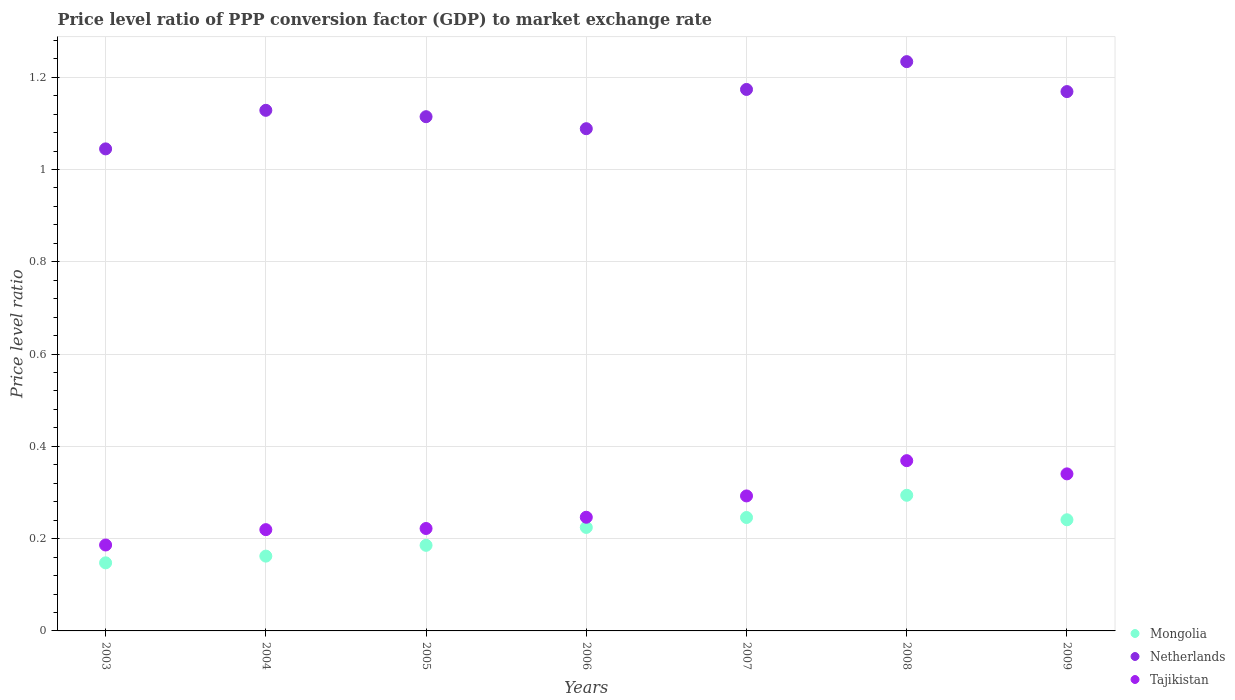Is the number of dotlines equal to the number of legend labels?
Offer a terse response. Yes. What is the price level ratio in Tajikistan in 2008?
Give a very brief answer. 0.37. Across all years, what is the maximum price level ratio in Netherlands?
Make the answer very short. 1.23. Across all years, what is the minimum price level ratio in Tajikistan?
Offer a very short reply. 0.19. In which year was the price level ratio in Tajikistan maximum?
Provide a short and direct response. 2008. In which year was the price level ratio in Mongolia minimum?
Your response must be concise. 2003. What is the total price level ratio in Netherlands in the graph?
Ensure brevity in your answer.  7.95. What is the difference between the price level ratio in Tajikistan in 2003 and that in 2005?
Keep it short and to the point. -0.04. What is the difference between the price level ratio in Netherlands in 2004 and the price level ratio in Mongolia in 2007?
Your answer should be very brief. 0.88. What is the average price level ratio in Tajikistan per year?
Offer a very short reply. 0.27. In the year 2003, what is the difference between the price level ratio in Tajikistan and price level ratio in Netherlands?
Your answer should be compact. -0.86. What is the ratio of the price level ratio in Mongolia in 2004 to that in 2007?
Your answer should be very brief. 0.66. Is the price level ratio in Netherlands in 2003 less than that in 2006?
Your answer should be compact. Yes. What is the difference between the highest and the second highest price level ratio in Mongolia?
Your answer should be very brief. 0.05. What is the difference between the highest and the lowest price level ratio in Tajikistan?
Offer a very short reply. 0.18. In how many years, is the price level ratio in Mongolia greater than the average price level ratio in Mongolia taken over all years?
Keep it short and to the point. 4. Is it the case that in every year, the sum of the price level ratio in Tajikistan and price level ratio in Mongolia  is greater than the price level ratio in Netherlands?
Provide a short and direct response. No. Does the price level ratio in Mongolia monotonically increase over the years?
Ensure brevity in your answer.  No. Is the price level ratio in Mongolia strictly greater than the price level ratio in Netherlands over the years?
Your response must be concise. No. How many years are there in the graph?
Offer a terse response. 7. Does the graph contain any zero values?
Your answer should be very brief. No. Where does the legend appear in the graph?
Offer a very short reply. Bottom right. How are the legend labels stacked?
Offer a terse response. Vertical. What is the title of the graph?
Provide a succinct answer. Price level ratio of PPP conversion factor (GDP) to market exchange rate. Does "Lesotho" appear as one of the legend labels in the graph?
Your answer should be very brief. No. What is the label or title of the X-axis?
Ensure brevity in your answer.  Years. What is the label or title of the Y-axis?
Keep it short and to the point. Price level ratio. What is the Price level ratio of Mongolia in 2003?
Provide a short and direct response. 0.15. What is the Price level ratio in Netherlands in 2003?
Make the answer very short. 1.04. What is the Price level ratio in Tajikistan in 2003?
Your answer should be compact. 0.19. What is the Price level ratio of Mongolia in 2004?
Give a very brief answer. 0.16. What is the Price level ratio in Netherlands in 2004?
Your answer should be compact. 1.13. What is the Price level ratio of Tajikistan in 2004?
Provide a short and direct response. 0.22. What is the Price level ratio in Mongolia in 2005?
Your answer should be very brief. 0.19. What is the Price level ratio of Netherlands in 2005?
Your answer should be very brief. 1.11. What is the Price level ratio in Tajikistan in 2005?
Your response must be concise. 0.22. What is the Price level ratio of Mongolia in 2006?
Keep it short and to the point. 0.22. What is the Price level ratio in Netherlands in 2006?
Offer a terse response. 1.09. What is the Price level ratio in Tajikistan in 2006?
Offer a terse response. 0.25. What is the Price level ratio in Mongolia in 2007?
Your answer should be compact. 0.25. What is the Price level ratio of Netherlands in 2007?
Provide a succinct answer. 1.17. What is the Price level ratio in Tajikistan in 2007?
Ensure brevity in your answer.  0.29. What is the Price level ratio in Mongolia in 2008?
Offer a very short reply. 0.29. What is the Price level ratio in Netherlands in 2008?
Offer a very short reply. 1.23. What is the Price level ratio in Tajikistan in 2008?
Ensure brevity in your answer.  0.37. What is the Price level ratio in Mongolia in 2009?
Provide a succinct answer. 0.24. What is the Price level ratio of Netherlands in 2009?
Provide a short and direct response. 1.17. What is the Price level ratio of Tajikistan in 2009?
Provide a short and direct response. 0.34. Across all years, what is the maximum Price level ratio in Mongolia?
Provide a succinct answer. 0.29. Across all years, what is the maximum Price level ratio of Netherlands?
Provide a short and direct response. 1.23. Across all years, what is the maximum Price level ratio in Tajikistan?
Offer a terse response. 0.37. Across all years, what is the minimum Price level ratio in Mongolia?
Ensure brevity in your answer.  0.15. Across all years, what is the minimum Price level ratio of Netherlands?
Provide a succinct answer. 1.04. Across all years, what is the minimum Price level ratio in Tajikistan?
Ensure brevity in your answer.  0.19. What is the total Price level ratio of Mongolia in the graph?
Ensure brevity in your answer.  1.5. What is the total Price level ratio of Netherlands in the graph?
Keep it short and to the point. 7.95. What is the total Price level ratio in Tajikistan in the graph?
Your response must be concise. 1.88. What is the difference between the Price level ratio in Mongolia in 2003 and that in 2004?
Provide a short and direct response. -0.01. What is the difference between the Price level ratio in Netherlands in 2003 and that in 2004?
Make the answer very short. -0.08. What is the difference between the Price level ratio of Tajikistan in 2003 and that in 2004?
Give a very brief answer. -0.03. What is the difference between the Price level ratio of Mongolia in 2003 and that in 2005?
Offer a terse response. -0.04. What is the difference between the Price level ratio in Netherlands in 2003 and that in 2005?
Your answer should be compact. -0.07. What is the difference between the Price level ratio of Tajikistan in 2003 and that in 2005?
Provide a short and direct response. -0.04. What is the difference between the Price level ratio of Mongolia in 2003 and that in 2006?
Offer a terse response. -0.08. What is the difference between the Price level ratio of Netherlands in 2003 and that in 2006?
Your answer should be compact. -0.04. What is the difference between the Price level ratio of Tajikistan in 2003 and that in 2006?
Provide a short and direct response. -0.06. What is the difference between the Price level ratio in Mongolia in 2003 and that in 2007?
Your answer should be very brief. -0.1. What is the difference between the Price level ratio in Netherlands in 2003 and that in 2007?
Give a very brief answer. -0.13. What is the difference between the Price level ratio in Tajikistan in 2003 and that in 2007?
Give a very brief answer. -0.11. What is the difference between the Price level ratio in Mongolia in 2003 and that in 2008?
Offer a very short reply. -0.15. What is the difference between the Price level ratio in Netherlands in 2003 and that in 2008?
Provide a succinct answer. -0.19. What is the difference between the Price level ratio in Tajikistan in 2003 and that in 2008?
Give a very brief answer. -0.18. What is the difference between the Price level ratio of Mongolia in 2003 and that in 2009?
Ensure brevity in your answer.  -0.09. What is the difference between the Price level ratio in Netherlands in 2003 and that in 2009?
Provide a succinct answer. -0.12. What is the difference between the Price level ratio of Tajikistan in 2003 and that in 2009?
Provide a succinct answer. -0.15. What is the difference between the Price level ratio in Mongolia in 2004 and that in 2005?
Your response must be concise. -0.02. What is the difference between the Price level ratio in Netherlands in 2004 and that in 2005?
Your answer should be compact. 0.01. What is the difference between the Price level ratio of Tajikistan in 2004 and that in 2005?
Provide a short and direct response. -0. What is the difference between the Price level ratio of Mongolia in 2004 and that in 2006?
Provide a short and direct response. -0.06. What is the difference between the Price level ratio of Netherlands in 2004 and that in 2006?
Make the answer very short. 0.04. What is the difference between the Price level ratio of Tajikistan in 2004 and that in 2006?
Your response must be concise. -0.03. What is the difference between the Price level ratio of Mongolia in 2004 and that in 2007?
Your response must be concise. -0.08. What is the difference between the Price level ratio in Netherlands in 2004 and that in 2007?
Give a very brief answer. -0.05. What is the difference between the Price level ratio in Tajikistan in 2004 and that in 2007?
Make the answer very short. -0.07. What is the difference between the Price level ratio in Mongolia in 2004 and that in 2008?
Provide a short and direct response. -0.13. What is the difference between the Price level ratio of Netherlands in 2004 and that in 2008?
Provide a short and direct response. -0.11. What is the difference between the Price level ratio in Tajikistan in 2004 and that in 2008?
Provide a succinct answer. -0.15. What is the difference between the Price level ratio in Mongolia in 2004 and that in 2009?
Keep it short and to the point. -0.08. What is the difference between the Price level ratio of Netherlands in 2004 and that in 2009?
Give a very brief answer. -0.04. What is the difference between the Price level ratio in Tajikistan in 2004 and that in 2009?
Offer a terse response. -0.12. What is the difference between the Price level ratio of Mongolia in 2005 and that in 2006?
Your answer should be very brief. -0.04. What is the difference between the Price level ratio of Netherlands in 2005 and that in 2006?
Your response must be concise. 0.03. What is the difference between the Price level ratio in Tajikistan in 2005 and that in 2006?
Ensure brevity in your answer.  -0.02. What is the difference between the Price level ratio in Mongolia in 2005 and that in 2007?
Give a very brief answer. -0.06. What is the difference between the Price level ratio of Netherlands in 2005 and that in 2007?
Provide a succinct answer. -0.06. What is the difference between the Price level ratio in Tajikistan in 2005 and that in 2007?
Your answer should be compact. -0.07. What is the difference between the Price level ratio of Mongolia in 2005 and that in 2008?
Provide a succinct answer. -0.11. What is the difference between the Price level ratio of Netherlands in 2005 and that in 2008?
Ensure brevity in your answer.  -0.12. What is the difference between the Price level ratio in Tajikistan in 2005 and that in 2008?
Ensure brevity in your answer.  -0.15. What is the difference between the Price level ratio of Mongolia in 2005 and that in 2009?
Your answer should be very brief. -0.06. What is the difference between the Price level ratio in Netherlands in 2005 and that in 2009?
Make the answer very short. -0.05. What is the difference between the Price level ratio in Tajikistan in 2005 and that in 2009?
Your response must be concise. -0.12. What is the difference between the Price level ratio of Mongolia in 2006 and that in 2007?
Make the answer very short. -0.02. What is the difference between the Price level ratio in Netherlands in 2006 and that in 2007?
Your answer should be very brief. -0.09. What is the difference between the Price level ratio of Tajikistan in 2006 and that in 2007?
Keep it short and to the point. -0.05. What is the difference between the Price level ratio in Mongolia in 2006 and that in 2008?
Provide a succinct answer. -0.07. What is the difference between the Price level ratio of Netherlands in 2006 and that in 2008?
Offer a terse response. -0.15. What is the difference between the Price level ratio of Tajikistan in 2006 and that in 2008?
Give a very brief answer. -0.12. What is the difference between the Price level ratio in Mongolia in 2006 and that in 2009?
Your answer should be very brief. -0.02. What is the difference between the Price level ratio of Netherlands in 2006 and that in 2009?
Provide a succinct answer. -0.08. What is the difference between the Price level ratio in Tajikistan in 2006 and that in 2009?
Keep it short and to the point. -0.09. What is the difference between the Price level ratio in Mongolia in 2007 and that in 2008?
Offer a very short reply. -0.05. What is the difference between the Price level ratio of Netherlands in 2007 and that in 2008?
Offer a terse response. -0.06. What is the difference between the Price level ratio in Tajikistan in 2007 and that in 2008?
Offer a very short reply. -0.08. What is the difference between the Price level ratio of Mongolia in 2007 and that in 2009?
Provide a succinct answer. 0. What is the difference between the Price level ratio of Netherlands in 2007 and that in 2009?
Make the answer very short. 0. What is the difference between the Price level ratio in Tajikistan in 2007 and that in 2009?
Make the answer very short. -0.05. What is the difference between the Price level ratio in Mongolia in 2008 and that in 2009?
Provide a succinct answer. 0.05. What is the difference between the Price level ratio of Netherlands in 2008 and that in 2009?
Provide a succinct answer. 0.06. What is the difference between the Price level ratio of Tajikistan in 2008 and that in 2009?
Your response must be concise. 0.03. What is the difference between the Price level ratio in Mongolia in 2003 and the Price level ratio in Netherlands in 2004?
Make the answer very short. -0.98. What is the difference between the Price level ratio of Mongolia in 2003 and the Price level ratio of Tajikistan in 2004?
Your answer should be compact. -0.07. What is the difference between the Price level ratio of Netherlands in 2003 and the Price level ratio of Tajikistan in 2004?
Provide a short and direct response. 0.83. What is the difference between the Price level ratio in Mongolia in 2003 and the Price level ratio in Netherlands in 2005?
Keep it short and to the point. -0.97. What is the difference between the Price level ratio of Mongolia in 2003 and the Price level ratio of Tajikistan in 2005?
Offer a very short reply. -0.07. What is the difference between the Price level ratio in Netherlands in 2003 and the Price level ratio in Tajikistan in 2005?
Make the answer very short. 0.82. What is the difference between the Price level ratio of Mongolia in 2003 and the Price level ratio of Netherlands in 2006?
Provide a succinct answer. -0.94. What is the difference between the Price level ratio of Mongolia in 2003 and the Price level ratio of Tajikistan in 2006?
Give a very brief answer. -0.1. What is the difference between the Price level ratio of Netherlands in 2003 and the Price level ratio of Tajikistan in 2006?
Keep it short and to the point. 0.8. What is the difference between the Price level ratio in Mongolia in 2003 and the Price level ratio in Netherlands in 2007?
Your answer should be compact. -1.03. What is the difference between the Price level ratio in Mongolia in 2003 and the Price level ratio in Tajikistan in 2007?
Your answer should be compact. -0.14. What is the difference between the Price level ratio in Netherlands in 2003 and the Price level ratio in Tajikistan in 2007?
Offer a terse response. 0.75. What is the difference between the Price level ratio in Mongolia in 2003 and the Price level ratio in Netherlands in 2008?
Your response must be concise. -1.09. What is the difference between the Price level ratio of Mongolia in 2003 and the Price level ratio of Tajikistan in 2008?
Provide a succinct answer. -0.22. What is the difference between the Price level ratio of Netherlands in 2003 and the Price level ratio of Tajikistan in 2008?
Offer a very short reply. 0.68. What is the difference between the Price level ratio of Mongolia in 2003 and the Price level ratio of Netherlands in 2009?
Your answer should be very brief. -1.02. What is the difference between the Price level ratio in Mongolia in 2003 and the Price level ratio in Tajikistan in 2009?
Provide a succinct answer. -0.19. What is the difference between the Price level ratio of Netherlands in 2003 and the Price level ratio of Tajikistan in 2009?
Ensure brevity in your answer.  0.7. What is the difference between the Price level ratio of Mongolia in 2004 and the Price level ratio of Netherlands in 2005?
Offer a very short reply. -0.95. What is the difference between the Price level ratio of Mongolia in 2004 and the Price level ratio of Tajikistan in 2005?
Provide a short and direct response. -0.06. What is the difference between the Price level ratio in Netherlands in 2004 and the Price level ratio in Tajikistan in 2005?
Give a very brief answer. 0.91. What is the difference between the Price level ratio in Mongolia in 2004 and the Price level ratio in Netherlands in 2006?
Offer a terse response. -0.93. What is the difference between the Price level ratio of Mongolia in 2004 and the Price level ratio of Tajikistan in 2006?
Your answer should be very brief. -0.08. What is the difference between the Price level ratio in Netherlands in 2004 and the Price level ratio in Tajikistan in 2006?
Give a very brief answer. 0.88. What is the difference between the Price level ratio of Mongolia in 2004 and the Price level ratio of Netherlands in 2007?
Your answer should be compact. -1.01. What is the difference between the Price level ratio in Mongolia in 2004 and the Price level ratio in Tajikistan in 2007?
Your answer should be very brief. -0.13. What is the difference between the Price level ratio of Netherlands in 2004 and the Price level ratio of Tajikistan in 2007?
Ensure brevity in your answer.  0.84. What is the difference between the Price level ratio of Mongolia in 2004 and the Price level ratio of Netherlands in 2008?
Make the answer very short. -1.07. What is the difference between the Price level ratio in Mongolia in 2004 and the Price level ratio in Tajikistan in 2008?
Offer a terse response. -0.21. What is the difference between the Price level ratio of Netherlands in 2004 and the Price level ratio of Tajikistan in 2008?
Offer a very short reply. 0.76. What is the difference between the Price level ratio of Mongolia in 2004 and the Price level ratio of Netherlands in 2009?
Your response must be concise. -1.01. What is the difference between the Price level ratio in Mongolia in 2004 and the Price level ratio in Tajikistan in 2009?
Your answer should be very brief. -0.18. What is the difference between the Price level ratio in Netherlands in 2004 and the Price level ratio in Tajikistan in 2009?
Ensure brevity in your answer.  0.79. What is the difference between the Price level ratio of Mongolia in 2005 and the Price level ratio of Netherlands in 2006?
Offer a terse response. -0.9. What is the difference between the Price level ratio of Mongolia in 2005 and the Price level ratio of Tajikistan in 2006?
Make the answer very short. -0.06. What is the difference between the Price level ratio of Netherlands in 2005 and the Price level ratio of Tajikistan in 2006?
Your response must be concise. 0.87. What is the difference between the Price level ratio in Mongolia in 2005 and the Price level ratio in Netherlands in 2007?
Give a very brief answer. -0.99. What is the difference between the Price level ratio in Mongolia in 2005 and the Price level ratio in Tajikistan in 2007?
Ensure brevity in your answer.  -0.11. What is the difference between the Price level ratio of Netherlands in 2005 and the Price level ratio of Tajikistan in 2007?
Offer a terse response. 0.82. What is the difference between the Price level ratio of Mongolia in 2005 and the Price level ratio of Netherlands in 2008?
Your answer should be very brief. -1.05. What is the difference between the Price level ratio in Mongolia in 2005 and the Price level ratio in Tajikistan in 2008?
Ensure brevity in your answer.  -0.18. What is the difference between the Price level ratio in Netherlands in 2005 and the Price level ratio in Tajikistan in 2008?
Ensure brevity in your answer.  0.75. What is the difference between the Price level ratio of Mongolia in 2005 and the Price level ratio of Netherlands in 2009?
Ensure brevity in your answer.  -0.98. What is the difference between the Price level ratio in Mongolia in 2005 and the Price level ratio in Tajikistan in 2009?
Your answer should be compact. -0.15. What is the difference between the Price level ratio in Netherlands in 2005 and the Price level ratio in Tajikistan in 2009?
Provide a short and direct response. 0.77. What is the difference between the Price level ratio in Mongolia in 2006 and the Price level ratio in Netherlands in 2007?
Your response must be concise. -0.95. What is the difference between the Price level ratio of Mongolia in 2006 and the Price level ratio of Tajikistan in 2007?
Make the answer very short. -0.07. What is the difference between the Price level ratio of Netherlands in 2006 and the Price level ratio of Tajikistan in 2007?
Ensure brevity in your answer.  0.8. What is the difference between the Price level ratio in Mongolia in 2006 and the Price level ratio in Netherlands in 2008?
Make the answer very short. -1.01. What is the difference between the Price level ratio in Mongolia in 2006 and the Price level ratio in Tajikistan in 2008?
Keep it short and to the point. -0.14. What is the difference between the Price level ratio of Netherlands in 2006 and the Price level ratio of Tajikistan in 2008?
Your answer should be compact. 0.72. What is the difference between the Price level ratio in Mongolia in 2006 and the Price level ratio in Netherlands in 2009?
Ensure brevity in your answer.  -0.94. What is the difference between the Price level ratio in Mongolia in 2006 and the Price level ratio in Tajikistan in 2009?
Your answer should be compact. -0.12. What is the difference between the Price level ratio of Netherlands in 2006 and the Price level ratio of Tajikistan in 2009?
Your answer should be very brief. 0.75. What is the difference between the Price level ratio in Mongolia in 2007 and the Price level ratio in Netherlands in 2008?
Ensure brevity in your answer.  -0.99. What is the difference between the Price level ratio in Mongolia in 2007 and the Price level ratio in Tajikistan in 2008?
Your answer should be very brief. -0.12. What is the difference between the Price level ratio of Netherlands in 2007 and the Price level ratio of Tajikistan in 2008?
Keep it short and to the point. 0.8. What is the difference between the Price level ratio of Mongolia in 2007 and the Price level ratio of Netherlands in 2009?
Provide a succinct answer. -0.92. What is the difference between the Price level ratio of Mongolia in 2007 and the Price level ratio of Tajikistan in 2009?
Ensure brevity in your answer.  -0.09. What is the difference between the Price level ratio of Netherlands in 2007 and the Price level ratio of Tajikistan in 2009?
Provide a short and direct response. 0.83. What is the difference between the Price level ratio of Mongolia in 2008 and the Price level ratio of Netherlands in 2009?
Give a very brief answer. -0.87. What is the difference between the Price level ratio in Mongolia in 2008 and the Price level ratio in Tajikistan in 2009?
Ensure brevity in your answer.  -0.05. What is the difference between the Price level ratio of Netherlands in 2008 and the Price level ratio of Tajikistan in 2009?
Offer a terse response. 0.89. What is the average Price level ratio of Mongolia per year?
Ensure brevity in your answer.  0.21. What is the average Price level ratio in Netherlands per year?
Offer a terse response. 1.14. What is the average Price level ratio of Tajikistan per year?
Make the answer very short. 0.27. In the year 2003, what is the difference between the Price level ratio of Mongolia and Price level ratio of Netherlands?
Provide a succinct answer. -0.9. In the year 2003, what is the difference between the Price level ratio in Mongolia and Price level ratio in Tajikistan?
Your response must be concise. -0.04. In the year 2003, what is the difference between the Price level ratio in Netherlands and Price level ratio in Tajikistan?
Ensure brevity in your answer.  0.86. In the year 2004, what is the difference between the Price level ratio of Mongolia and Price level ratio of Netherlands?
Your answer should be very brief. -0.97. In the year 2004, what is the difference between the Price level ratio of Mongolia and Price level ratio of Tajikistan?
Provide a succinct answer. -0.06. In the year 2004, what is the difference between the Price level ratio of Netherlands and Price level ratio of Tajikistan?
Your answer should be very brief. 0.91. In the year 2005, what is the difference between the Price level ratio of Mongolia and Price level ratio of Netherlands?
Offer a terse response. -0.93. In the year 2005, what is the difference between the Price level ratio of Mongolia and Price level ratio of Tajikistan?
Offer a terse response. -0.04. In the year 2005, what is the difference between the Price level ratio in Netherlands and Price level ratio in Tajikistan?
Give a very brief answer. 0.89. In the year 2006, what is the difference between the Price level ratio in Mongolia and Price level ratio in Netherlands?
Your answer should be very brief. -0.86. In the year 2006, what is the difference between the Price level ratio in Mongolia and Price level ratio in Tajikistan?
Offer a terse response. -0.02. In the year 2006, what is the difference between the Price level ratio in Netherlands and Price level ratio in Tajikistan?
Provide a short and direct response. 0.84. In the year 2007, what is the difference between the Price level ratio of Mongolia and Price level ratio of Netherlands?
Provide a short and direct response. -0.93. In the year 2007, what is the difference between the Price level ratio of Mongolia and Price level ratio of Tajikistan?
Provide a succinct answer. -0.05. In the year 2007, what is the difference between the Price level ratio of Netherlands and Price level ratio of Tajikistan?
Your answer should be compact. 0.88. In the year 2008, what is the difference between the Price level ratio in Mongolia and Price level ratio in Netherlands?
Provide a succinct answer. -0.94. In the year 2008, what is the difference between the Price level ratio of Mongolia and Price level ratio of Tajikistan?
Your response must be concise. -0.07. In the year 2008, what is the difference between the Price level ratio of Netherlands and Price level ratio of Tajikistan?
Provide a short and direct response. 0.86. In the year 2009, what is the difference between the Price level ratio of Mongolia and Price level ratio of Netherlands?
Make the answer very short. -0.93. In the year 2009, what is the difference between the Price level ratio in Mongolia and Price level ratio in Tajikistan?
Your response must be concise. -0.1. In the year 2009, what is the difference between the Price level ratio of Netherlands and Price level ratio of Tajikistan?
Your answer should be compact. 0.83. What is the ratio of the Price level ratio of Mongolia in 2003 to that in 2004?
Give a very brief answer. 0.91. What is the ratio of the Price level ratio of Netherlands in 2003 to that in 2004?
Offer a terse response. 0.93. What is the ratio of the Price level ratio in Tajikistan in 2003 to that in 2004?
Make the answer very short. 0.85. What is the ratio of the Price level ratio in Mongolia in 2003 to that in 2005?
Give a very brief answer. 0.8. What is the ratio of the Price level ratio in Netherlands in 2003 to that in 2005?
Offer a terse response. 0.94. What is the ratio of the Price level ratio in Tajikistan in 2003 to that in 2005?
Offer a terse response. 0.84. What is the ratio of the Price level ratio in Mongolia in 2003 to that in 2006?
Ensure brevity in your answer.  0.66. What is the ratio of the Price level ratio in Netherlands in 2003 to that in 2006?
Provide a succinct answer. 0.96. What is the ratio of the Price level ratio of Tajikistan in 2003 to that in 2006?
Offer a terse response. 0.76. What is the ratio of the Price level ratio of Mongolia in 2003 to that in 2007?
Your answer should be very brief. 0.6. What is the ratio of the Price level ratio in Netherlands in 2003 to that in 2007?
Offer a terse response. 0.89. What is the ratio of the Price level ratio in Tajikistan in 2003 to that in 2007?
Your response must be concise. 0.64. What is the ratio of the Price level ratio of Mongolia in 2003 to that in 2008?
Ensure brevity in your answer.  0.5. What is the ratio of the Price level ratio in Netherlands in 2003 to that in 2008?
Your response must be concise. 0.85. What is the ratio of the Price level ratio of Tajikistan in 2003 to that in 2008?
Give a very brief answer. 0.5. What is the ratio of the Price level ratio in Mongolia in 2003 to that in 2009?
Keep it short and to the point. 0.61. What is the ratio of the Price level ratio in Netherlands in 2003 to that in 2009?
Offer a very short reply. 0.89. What is the ratio of the Price level ratio in Tajikistan in 2003 to that in 2009?
Ensure brevity in your answer.  0.55. What is the ratio of the Price level ratio of Mongolia in 2004 to that in 2005?
Make the answer very short. 0.87. What is the ratio of the Price level ratio of Netherlands in 2004 to that in 2005?
Make the answer very short. 1.01. What is the ratio of the Price level ratio in Mongolia in 2004 to that in 2006?
Provide a short and direct response. 0.72. What is the ratio of the Price level ratio in Netherlands in 2004 to that in 2006?
Offer a terse response. 1.04. What is the ratio of the Price level ratio in Tajikistan in 2004 to that in 2006?
Provide a short and direct response. 0.89. What is the ratio of the Price level ratio in Mongolia in 2004 to that in 2007?
Provide a succinct answer. 0.66. What is the ratio of the Price level ratio of Netherlands in 2004 to that in 2007?
Provide a short and direct response. 0.96. What is the ratio of the Price level ratio in Tajikistan in 2004 to that in 2007?
Ensure brevity in your answer.  0.75. What is the ratio of the Price level ratio in Mongolia in 2004 to that in 2008?
Your answer should be compact. 0.55. What is the ratio of the Price level ratio in Netherlands in 2004 to that in 2008?
Make the answer very short. 0.91. What is the ratio of the Price level ratio of Tajikistan in 2004 to that in 2008?
Offer a terse response. 0.59. What is the ratio of the Price level ratio in Mongolia in 2004 to that in 2009?
Offer a very short reply. 0.67. What is the ratio of the Price level ratio in Netherlands in 2004 to that in 2009?
Offer a terse response. 0.97. What is the ratio of the Price level ratio in Tajikistan in 2004 to that in 2009?
Your response must be concise. 0.64. What is the ratio of the Price level ratio in Mongolia in 2005 to that in 2006?
Your response must be concise. 0.83. What is the ratio of the Price level ratio in Netherlands in 2005 to that in 2006?
Ensure brevity in your answer.  1.02. What is the ratio of the Price level ratio in Tajikistan in 2005 to that in 2006?
Provide a succinct answer. 0.9. What is the ratio of the Price level ratio of Mongolia in 2005 to that in 2007?
Offer a very short reply. 0.75. What is the ratio of the Price level ratio of Netherlands in 2005 to that in 2007?
Provide a succinct answer. 0.95. What is the ratio of the Price level ratio of Tajikistan in 2005 to that in 2007?
Make the answer very short. 0.76. What is the ratio of the Price level ratio of Mongolia in 2005 to that in 2008?
Ensure brevity in your answer.  0.63. What is the ratio of the Price level ratio of Netherlands in 2005 to that in 2008?
Ensure brevity in your answer.  0.9. What is the ratio of the Price level ratio in Tajikistan in 2005 to that in 2008?
Your answer should be compact. 0.6. What is the ratio of the Price level ratio in Mongolia in 2005 to that in 2009?
Provide a short and direct response. 0.77. What is the ratio of the Price level ratio in Netherlands in 2005 to that in 2009?
Ensure brevity in your answer.  0.95. What is the ratio of the Price level ratio of Tajikistan in 2005 to that in 2009?
Your answer should be compact. 0.65. What is the ratio of the Price level ratio of Mongolia in 2006 to that in 2007?
Your response must be concise. 0.91. What is the ratio of the Price level ratio of Netherlands in 2006 to that in 2007?
Give a very brief answer. 0.93. What is the ratio of the Price level ratio of Tajikistan in 2006 to that in 2007?
Give a very brief answer. 0.84. What is the ratio of the Price level ratio of Mongolia in 2006 to that in 2008?
Ensure brevity in your answer.  0.76. What is the ratio of the Price level ratio in Netherlands in 2006 to that in 2008?
Provide a succinct answer. 0.88. What is the ratio of the Price level ratio of Tajikistan in 2006 to that in 2008?
Provide a succinct answer. 0.67. What is the ratio of the Price level ratio in Mongolia in 2006 to that in 2009?
Your answer should be very brief. 0.93. What is the ratio of the Price level ratio in Netherlands in 2006 to that in 2009?
Your response must be concise. 0.93. What is the ratio of the Price level ratio of Tajikistan in 2006 to that in 2009?
Provide a succinct answer. 0.72. What is the ratio of the Price level ratio of Mongolia in 2007 to that in 2008?
Ensure brevity in your answer.  0.84. What is the ratio of the Price level ratio in Netherlands in 2007 to that in 2008?
Ensure brevity in your answer.  0.95. What is the ratio of the Price level ratio of Tajikistan in 2007 to that in 2008?
Provide a succinct answer. 0.79. What is the ratio of the Price level ratio in Mongolia in 2007 to that in 2009?
Provide a succinct answer. 1.02. What is the ratio of the Price level ratio of Tajikistan in 2007 to that in 2009?
Your response must be concise. 0.86. What is the ratio of the Price level ratio in Mongolia in 2008 to that in 2009?
Make the answer very short. 1.22. What is the ratio of the Price level ratio of Netherlands in 2008 to that in 2009?
Offer a very short reply. 1.06. What is the ratio of the Price level ratio in Tajikistan in 2008 to that in 2009?
Your answer should be compact. 1.08. What is the difference between the highest and the second highest Price level ratio in Mongolia?
Keep it short and to the point. 0.05. What is the difference between the highest and the second highest Price level ratio of Netherlands?
Your answer should be very brief. 0.06. What is the difference between the highest and the second highest Price level ratio of Tajikistan?
Provide a succinct answer. 0.03. What is the difference between the highest and the lowest Price level ratio in Mongolia?
Your answer should be compact. 0.15. What is the difference between the highest and the lowest Price level ratio of Netherlands?
Your response must be concise. 0.19. What is the difference between the highest and the lowest Price level ratio in Tajikistan?
Make the answer very short. 0.18. 